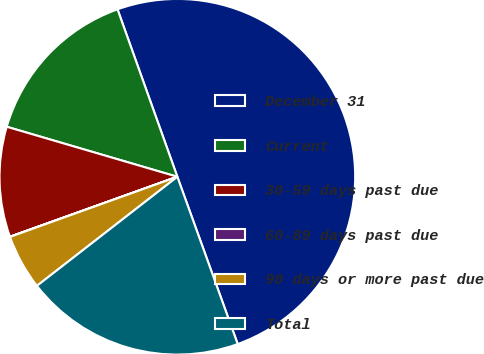Convert chart to OTSL. <chart><loc_0><loc_0><loc_500><loc_500><pie_chart><fcel>December 31<fcel>Current<fcel>30-59 days past due<fcel>60-89 days past due<fcel>90 days or more past due<fcel>Total<nl><fcel>49.95%<fcel>15.0%<fcel>10.01%<fcel>0.02%<fcel>5.02%<fcel>20.0%<nl></chart> 